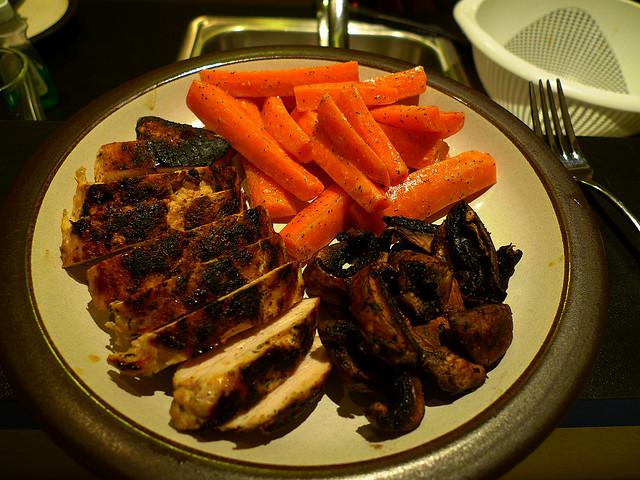How is the chicken cooked?
Concise answer only. Grilled. What is the orange food?
Be succinct. Carrots. Are there more vegetables on the plate than meat?
Give a very brief answer. No. 